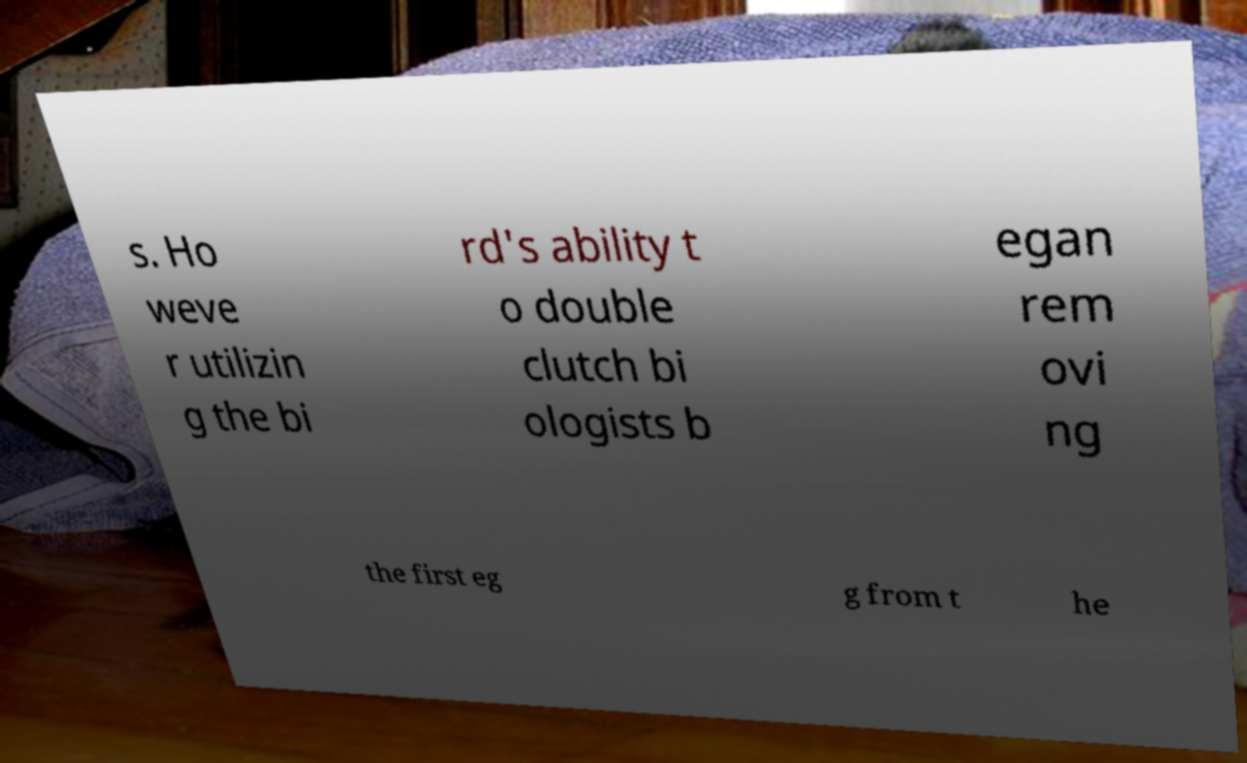Please identify and transcribe the text found in this image. s. Ho weve r utilizin g the bi rd's ability t o double clutch bi ologists b egan rem ovi ng the first eg g from t he 